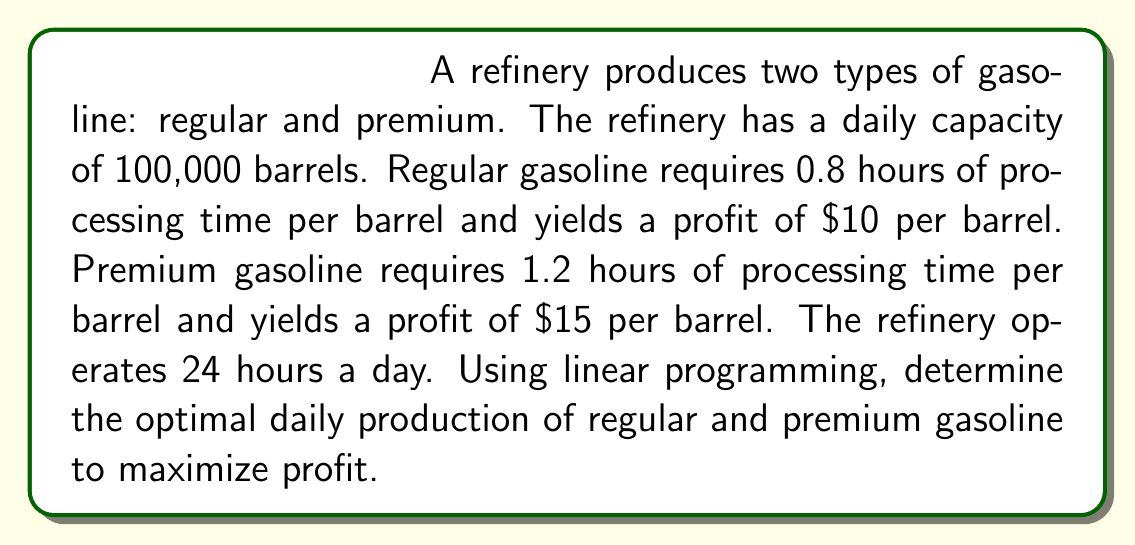Could you help me with this problem? Let's solve this problem using linear programming:

1. Define variables:
   Let $x$ = number of barrels of regular gasoline
   Let $y$ = number of barrels of premium gasoline

2. Objective function (maximize profit):
   $$ \text{Maximize } Z = 10x + 15y $$

3. Constraints:
   a) Total production capacity:
      $$ x + y \leq 100,000 $$
   b) Processing time:
      $$ 0.8x + 1.2y \leq 24 \times 60 = 1440 \text{ minutes} $$
   c) Non-negativity:
      $$ x \geq 0, y \geq 0 $$

4. Solve graphically or using the simplex method. In this case, we'll use the corner point method:

   Corner points:
   (0, 0), (100000, 0), (0, 1200), (60000, 40000)

   Evaluate Z at each point:
   (0, 0): Z = 0
   (100000, 0): Z = 1,000,000
   (0, 1200): Z = 18,000
   (60000, 40000): Z = 1,200,000

5. The optimal solution is at (60000, 40000), which gives the maximum profit of $1,200,000.
Answer: Produce 60,000 barrels of regular gasoline and 40,000 barrels of premium gasoline daily. 